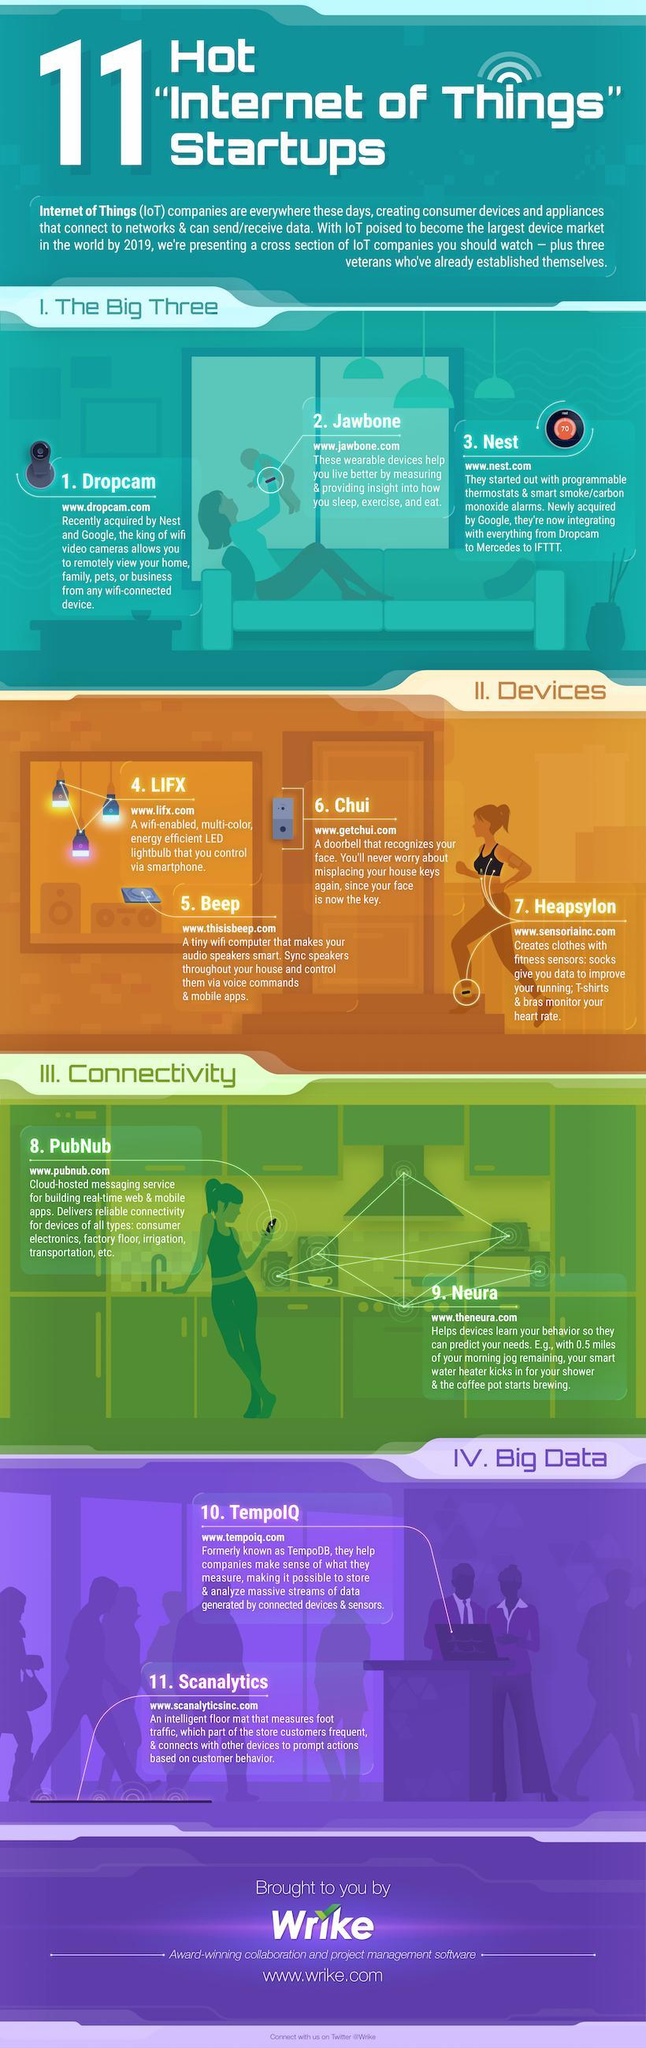What is the third point under the heading devices?
Answer the question with a short phrase. Chui What is the second point under the heading devices? Beep How many points are under the heading The Big Three? 3 How many points are under the heading connectivity? 2 How many points are under the heading of big data? 2 How many points are under the heading devices? 4 